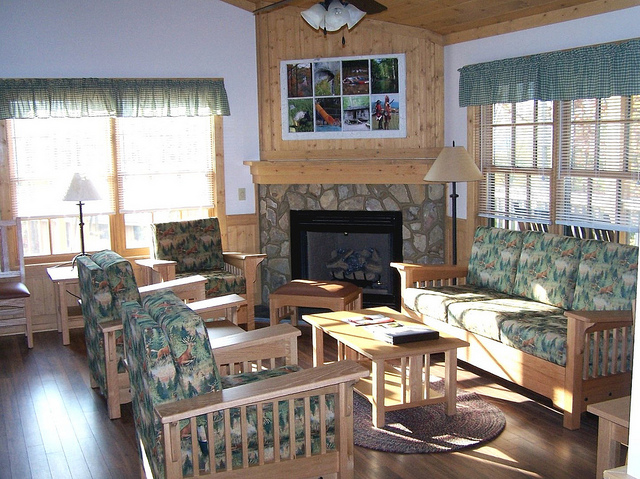<image>What is the design on the cushion? I don't know the exact design on the cushion. It could be a deer, a forest with deer, a floral design or a wildlife theme. What is the design on the cushion? I am not sure what the design on the cushion is. It can be seen as 'deer', 'forest with deer', 'floral', 'wildlife', 'native american', 'graphic print' or 'forest'. 